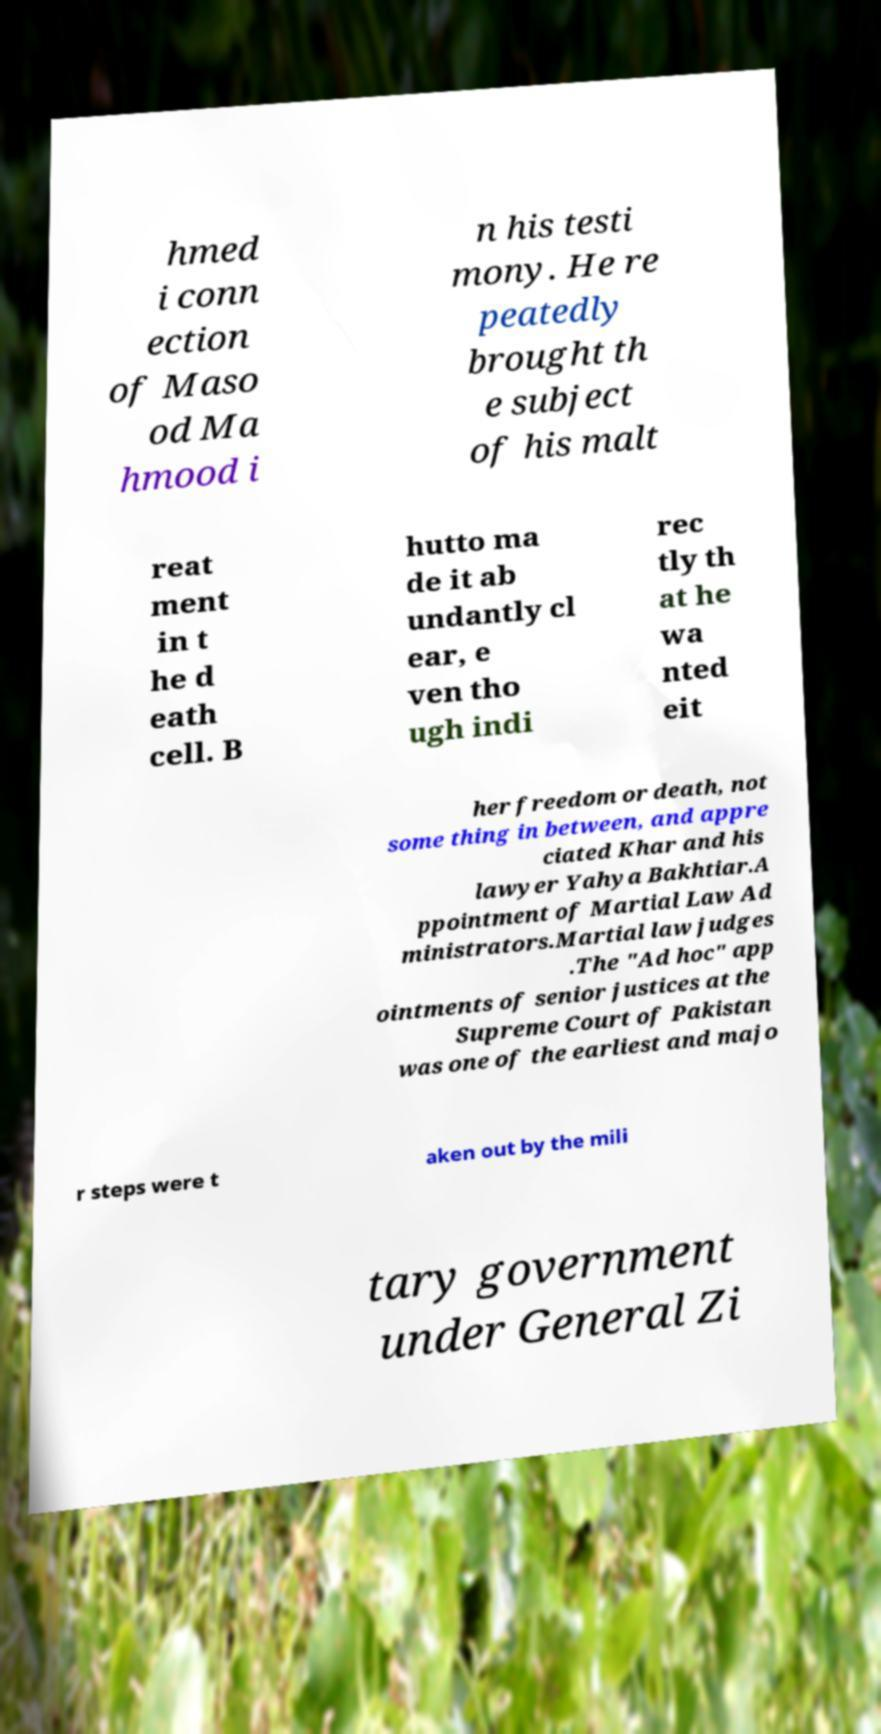Please identify and transcribe the text found in this image. hmed i conn ection of Maso od Ma hmood i n his testi mony. He re peatedly brought th e subject of his malt reat ment in t he d eath cell. B hutto ma de it ab undantly cl ear, e ven tho ugh indi rec tly th at he wa nted eit her freedom or death, not some thing in between, and appre ciated Khar and his lawyer Yahya Bakhtiar.A ppointment of Martial Law Ad ministrators.Martial law judges .The "Ad hoc" app ointments of senior justices at the Supreme Court of Pakistan was one of the earliest and majo r steps were t aken out by the mili tary government under General Zi 